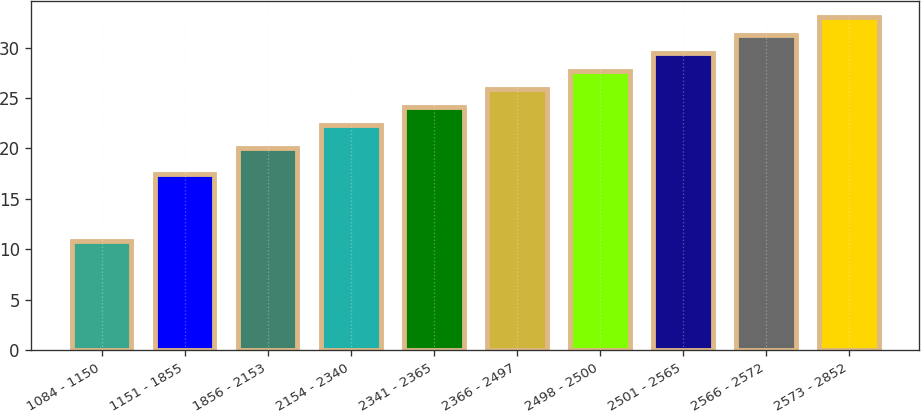Convert chart. <chart><loc_0><loc_0><loc_500><loc_500><bar_chart><fcel>1084 - 1150<fcel>1151 - 1855<fcel>1856 - 2153<fcel>2154 - 2340<fcel>2341 - 2365<fcel>2366 - 2497<fcel>2498 - 2500<fcel>2501 - 2565<fcel>2566 - 2572<fcel>2573 - 2852<nl><fcel>10.84<fcel>17.43<fcel>20.05<fcel>22.37<fcel>24.14<fcel>25.91<fcel>27.68<fcel>29.45<fcel>31.22<fcel>32.99<nl></chart> 